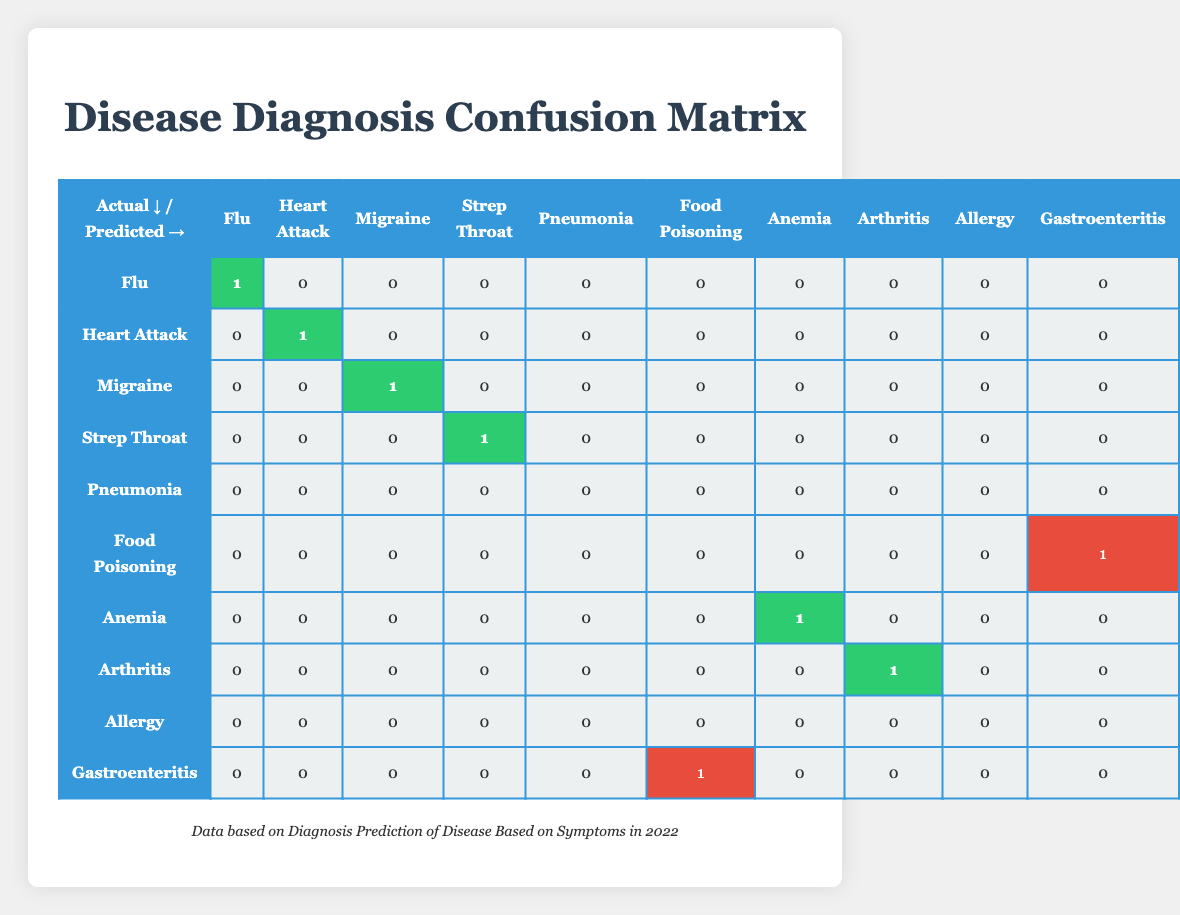What is the total number of correct predictions for the Flu diagnosis? There is 1 correct prediction for the Flu diagnosis as indicated in the confusion matrix.
Answer: 1 How many times was Gastroenteritis incorrectly predicted? There is 1 instance where Gastroenteritis was incorrectly predicted as Food Poisoning, as shown in the table.
Answer: 1 For which diagnosis was there a false positive? A false positive occurred when Pneumonia was incorrectly predicted as Asthma, as indicated in the table.
Answer: Pneumonia What is the sum of the correct predictions across all diagnoses? By adding the correct predictions: 1 (Flu) + 1 (Heart Attack) + 1 (Migraine) + 1 (Strep Throat) + 1 (Anemia) + 1 (Arthritis) = 6. Therefore, the total is 6.
Answer: 6 Was there any diagnosis that had a 100% accuracy in predictions? Yes, all of the following diagnoses had 100% accuracy: Flu, Heart Attack, Migraine, Strep Throat, Anemia, and Arthritis, each with 1 correct prediction and no incorrect ones.
Answer: Yes How many predictions for Allergy were made, and were any correct? There were 0 predictions made for Allergy, as shown in the table, indicating that all predictions were incorrect as there were none made.
Answer: 0 What is the average number of correct predictions per diagnosis? There are 6 correct predictions across 10 diagnoses. So, the average is 6/10 = 0.6.
Answer: 0.6 What is the difference between the total number of correct predictions and the total number of incorrect predictions? There are 6 correct predictions and 3 incorrect predictions (1 Gastroenteritis + 1 Pneumonia + 1 Allergy). The difference is 6 - 3 = 3.
Answer: 3 How many diagnoses were misclassified at least once? Four diagnoses were misclassified at least once (Pneumonia, Food Poisoning, Allergy, and Gastroenteritis) based on their incorrect predictions.
Answer: 4 